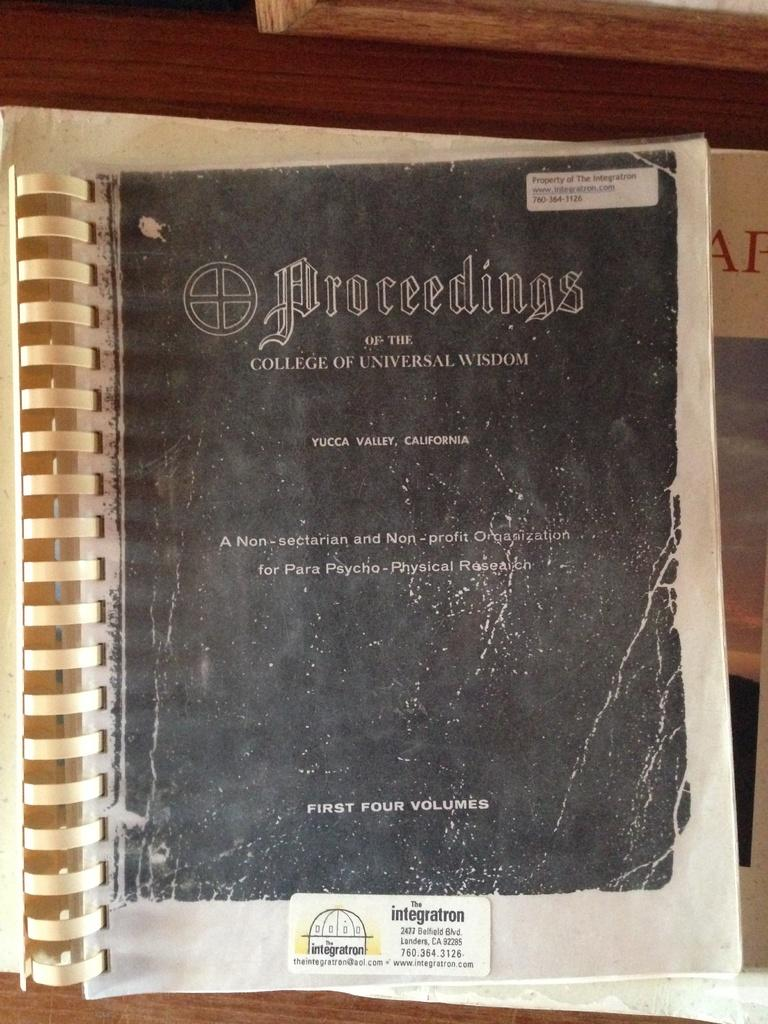Provide a one-sentence caption for the provided image. Proceedings of the College of Universal Wisdom book. 